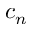Convert formula to latex. <formula><loc_0><loc_0><loc_500><loc_500>c _ { n }</formula> 